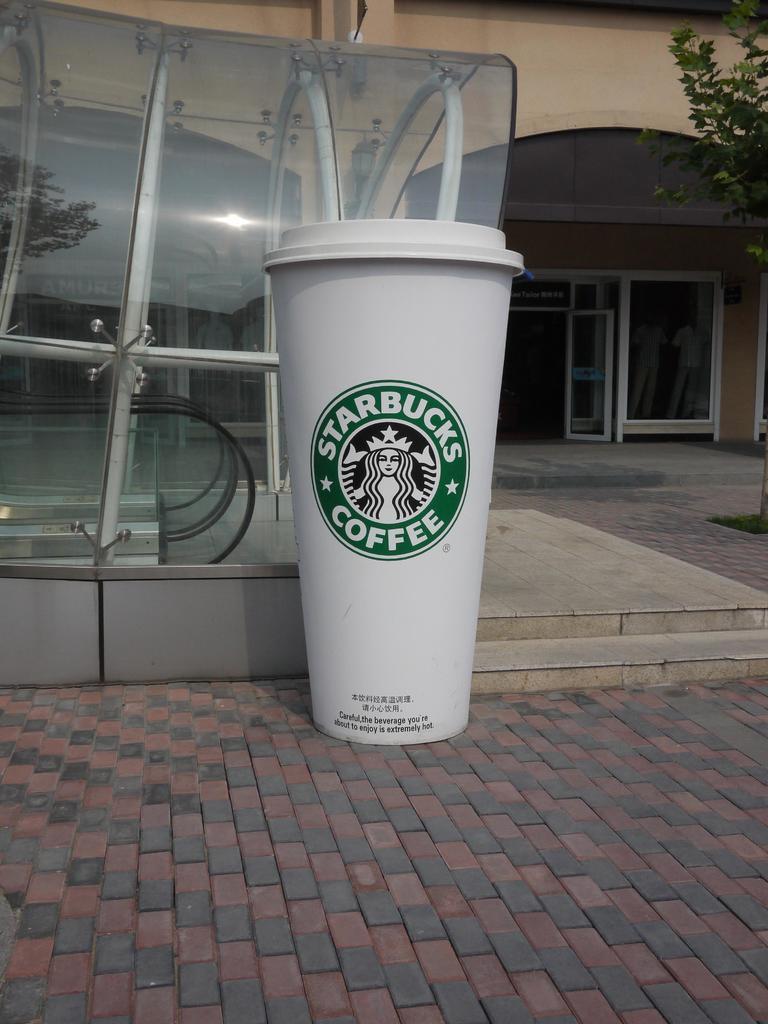In one or two sentences, can you explain what this image depicts? In this picture we can see white color Starbucks cup is placed on the floor. Behind there is a glass shed. In the background there is a building and glass door. 